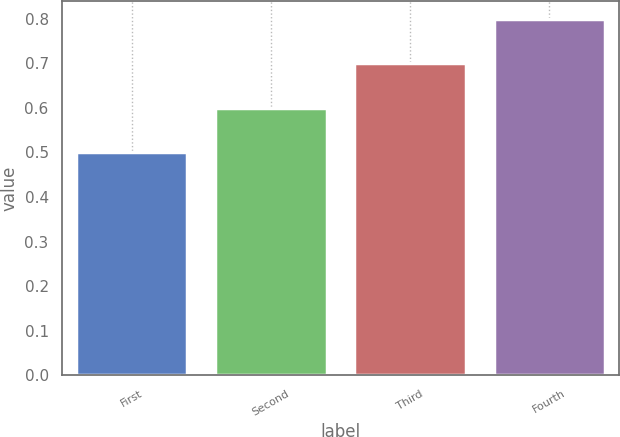Convert chart. <chart><loc_0><loc_0><loc_500><loc_500><bar_chart><fcel>First<fcel>Second<fcel>Third<fcel>Fourth<nl><fcel>0.5<fcel>0.6<fcel>0.7<fcel>0.8<nl></chart> 